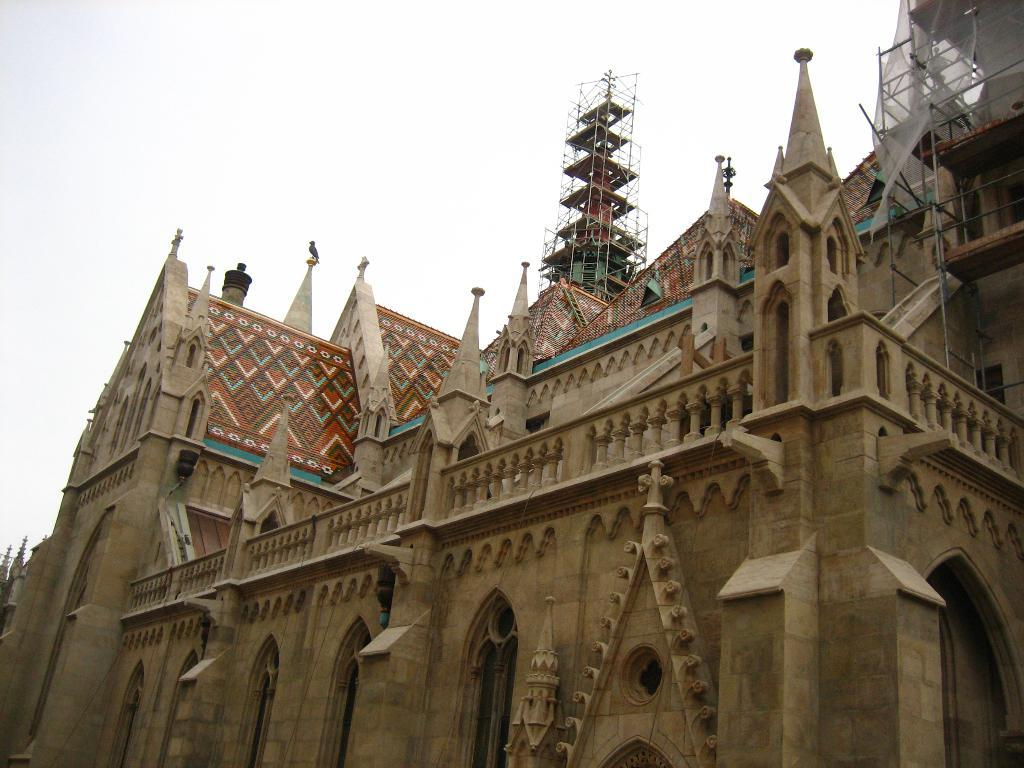What type of structure is present in the image? There is a building and a church in the image. What can be seen at the top of the image? The sky is visible at the top of the image, and clouds are present in the sky. Where is the entrance to the building located? There is a door visible at the bottom of the image. How many goldfish are swimming in the fountain in the image? There is no fountain or goldfish present in the image. What type of sticks are used to stir the soup in the image? There is no soup or sticks visible in the image. 